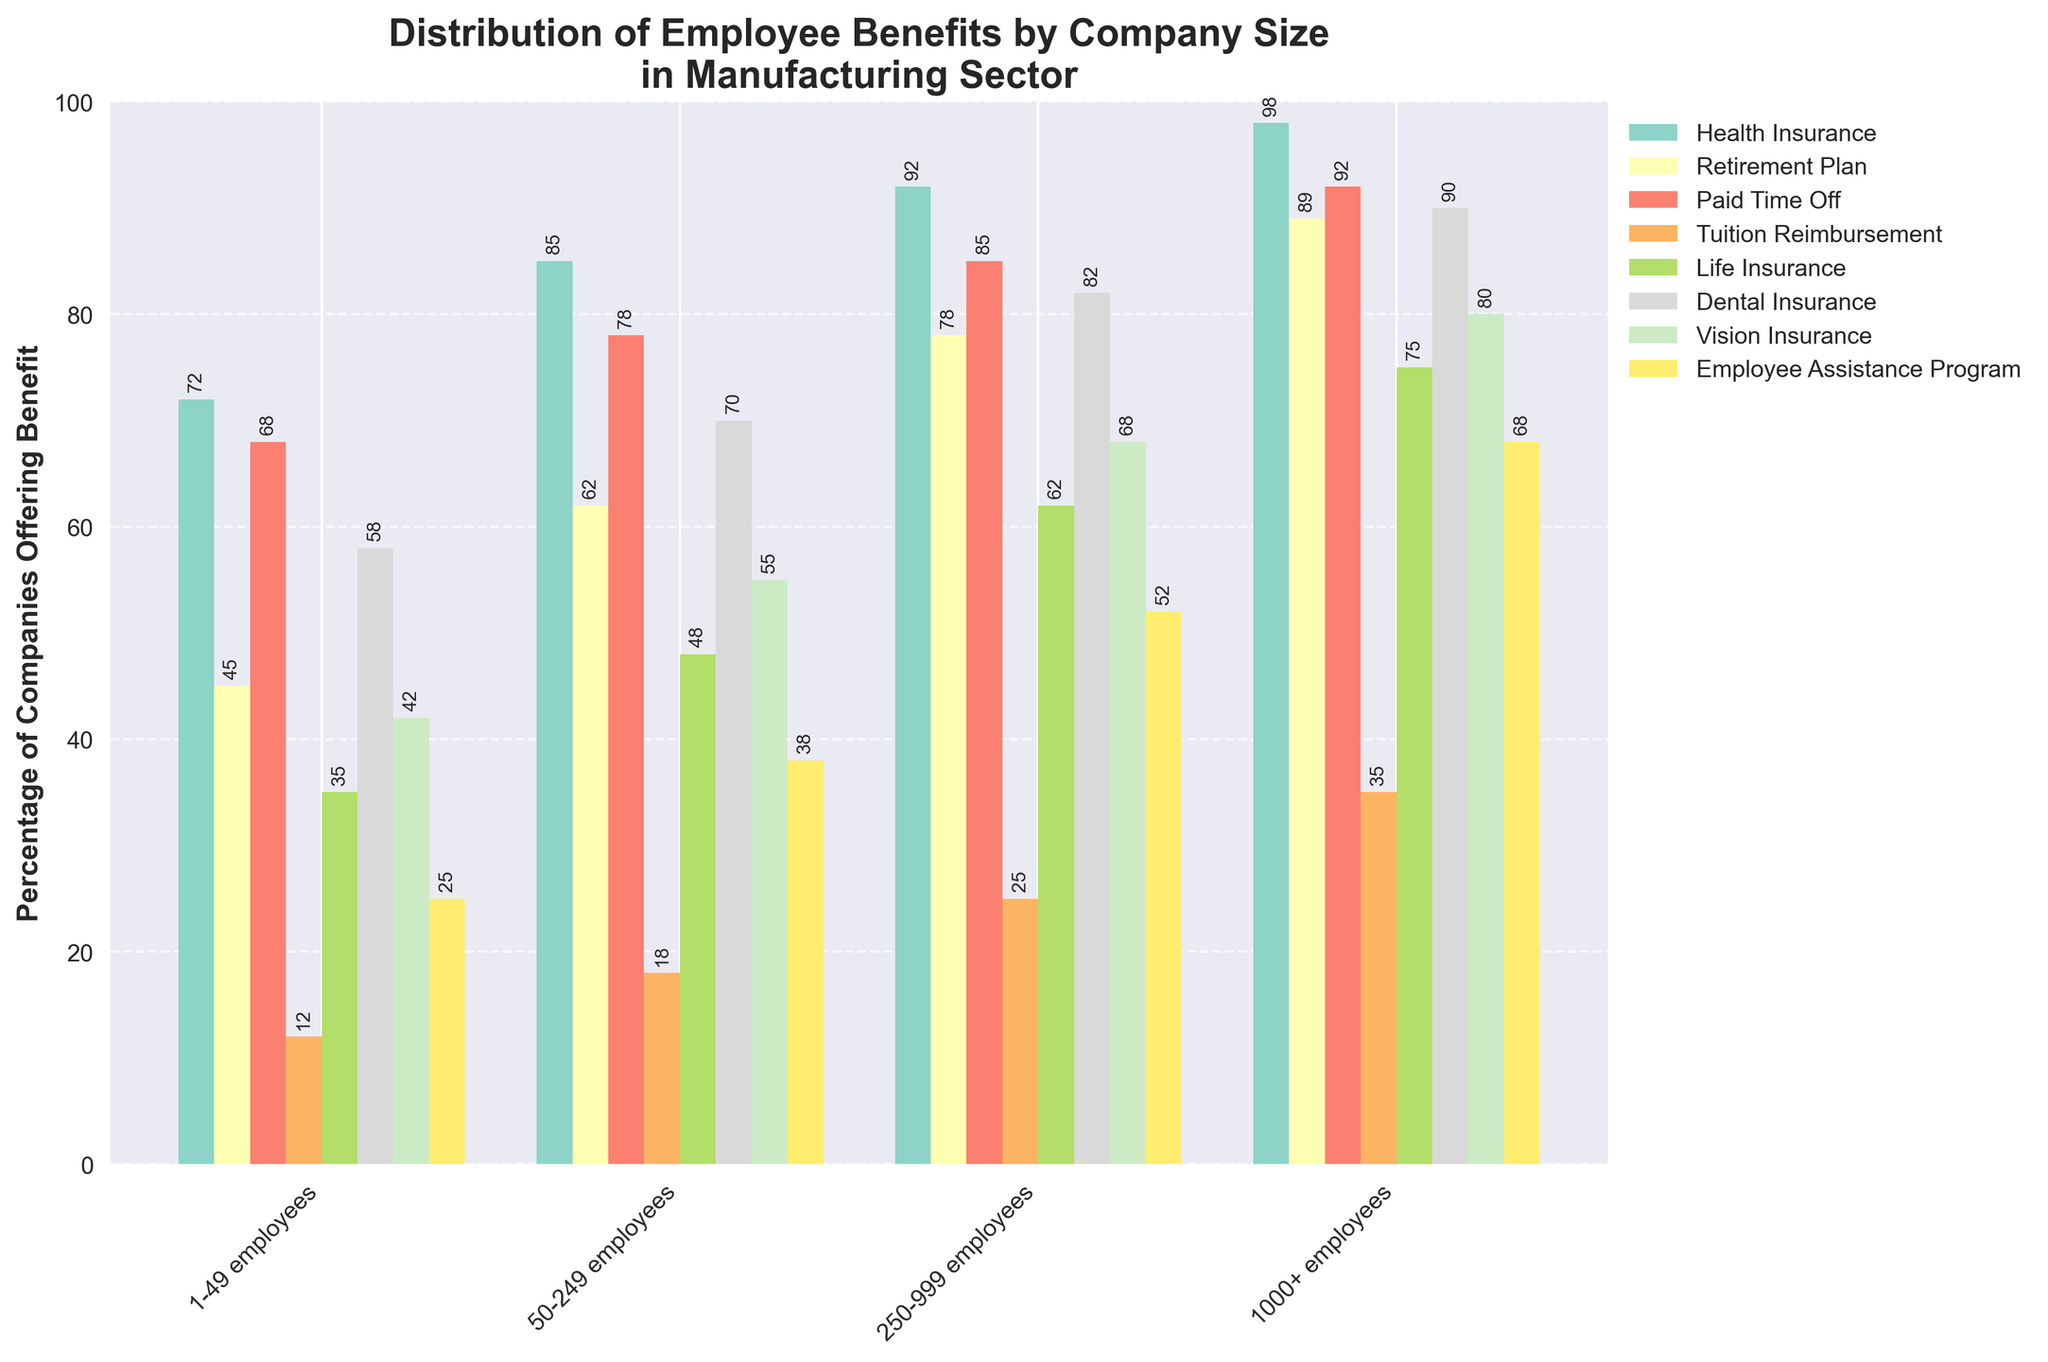Which company size offers the highest percentage of Paid Time Off? The bars for Paid Time Off are identified by their color. Look for the tallest bar among the different company sizes for Paid Time Off. In this case, the tallest bar is for the "1000+ employees" category at 92%.
Answer: 1000+ employees Which benefit sees the smallest increase in percentage offered from "1-49 employees" to "1000+ employees"? Calculate the difference in percentage between the "1000+ employees" and "1-49 employees" categories for each benefit. Tuition Reimbursement shows the smallest change: 35% - 12% = 23%.
Answer: Tuition Reimbursement Which benefit is offered by less than 20% of companies with "50-249 employees"? Look for the bar heights for the "50-249 employees" category. The only bar lower than 20% is Tuition Reimbursement, which is at 18%.
Answer: Tuition Reimbursement How many benefits are offered by at least 90% of companies with "1000+ employees"? Identify the number of bars that reach or exceed the 90% mark for the "1000+ employees" category. Benefits meeting this criterion are Health Insurance, Retirement Plan, Paid Time Off, and Dental Insurance.
Answer: 4 For companies with "250-999 employees," what is the difference in the percentage offering Health Insurance compared to Vision Insurance? Subtract the percentage offering Vision Insurance from the percentage offering Health Insurance in the "250-999 employees" category (92% - 68% = 24%).
Answer: 24% Which company size has a higher percentage offering Dental Insurance compared to Vision Insurance? Compare the bars for Dental Insurance and Vision Insurance for each company size. Every size group offers a higher percentage of Dental Insurance compared to Vision Insurance.
Answer: All company sizes What is the approximate average percentage of companies offering Life Insurance across all company sizes? Add the percentages for Life Insurance across all company sizes and divide by the number of categories: (35% + 48% + 62% + 75%) / 4 = 55%.
Answer: 55% Which benefit sees the largest increase in percentage offered from "50-249 employees" to "250-999 employees"? Calculate the difference for each benefit between these two categories. Vision Insurance has the largest increase: 68% - 55% = 13%.
Answer: Vision Insurance 